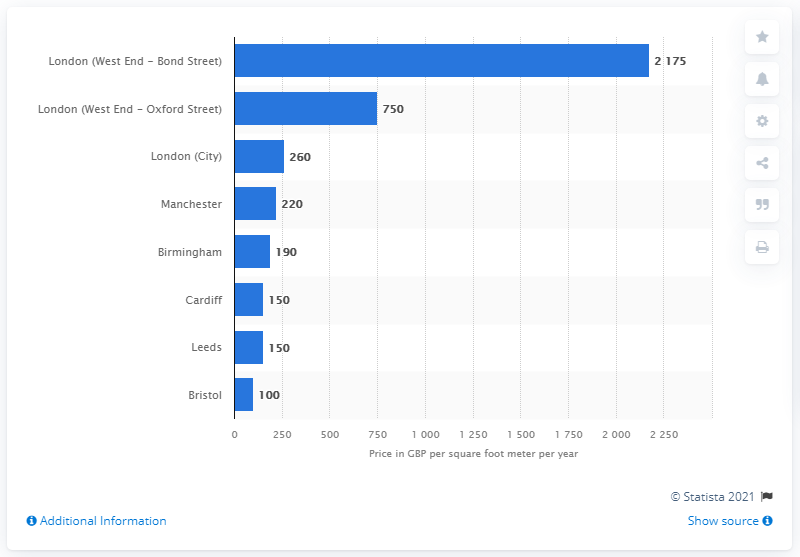Give some essential details in this illustration. The annual cost per square foot of prime retail real estate in Manchester was 220. 